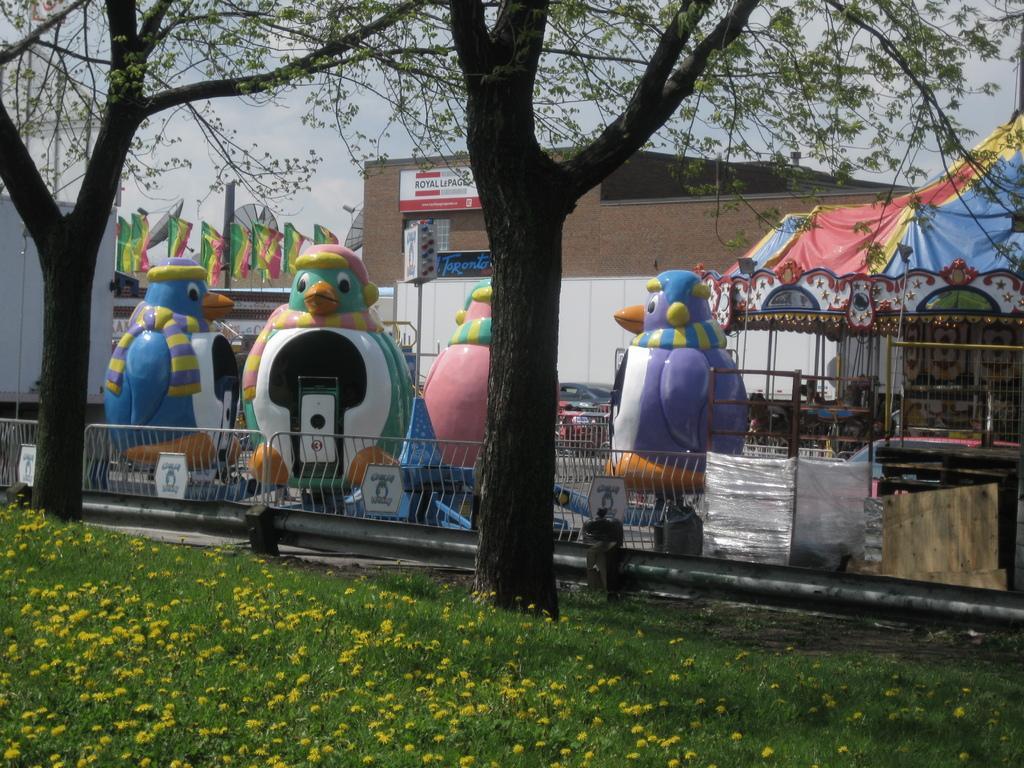Can you describe this image briefly? In this image I can see the grass. I can see the trees. In the background, I can see a building with some text written on it. 